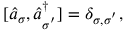Convert formula to latex. <formula><loc_0><loc_0><loc_500><loc_500>\begin{array} { r } { [ \hat { a } _ { \sigma } , \hat { a } _ { \sigma ^ { ^ { \prime } } } ^ { \dagger } ] = \delta _ { { \sigma } , { \sigma } ^ { ^ { \prime } } } , } \end{array}</formula> 